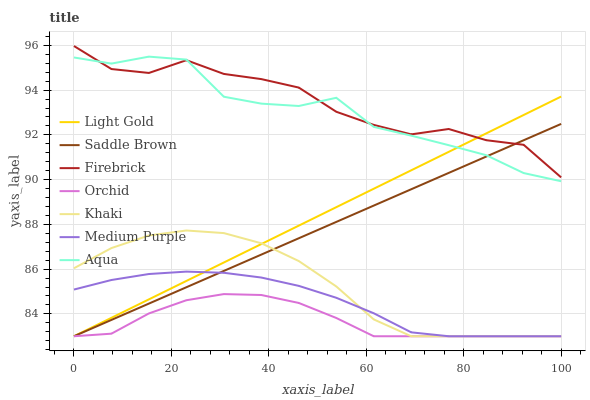Does Orchid have the minimum area under the curve?
Answer yes or no. Yes. Does Firebrick have the maximum area under the curve?
Answer yes or no. Yes. Does Aqua have the minimum area under the curve?
Answer yes or no. No. Does Aqua have the maximum area under the curve?
Answer yes or no. No. Is Light Gold the smoothest?
Answer yes or no. Yes. Is Aqua the roughest?
Answer yes or no. Yes. Is Firebrick the smoothest?
Answer yes or no. No. Is Firebrick the roughest?
Answer yes or no. No. Does Khaki have the lowest value?
Answer yes or no. Yes. Does Aqua have the lowest value?
Answer yes or no. No. Does Firebrick have the highest value?
Answer yes or no. Yes. Does Aqua have the highest value?
Answer yes or no. No. Is Khaki less than Aqua?
Answer yes or no. Yes. Is Aqua greater than Orchid?
Answer yes or no. Yes. Does Aqua intersect Light Gold?
Answer yes or no. Yes. Is Aqua less than Light Gold?
Answer yes or no. No. Is Aqua greater than Light Gold?
Answer yes or no. No. Does Khaki intersect Aqua?
Answer yes or no. No. 